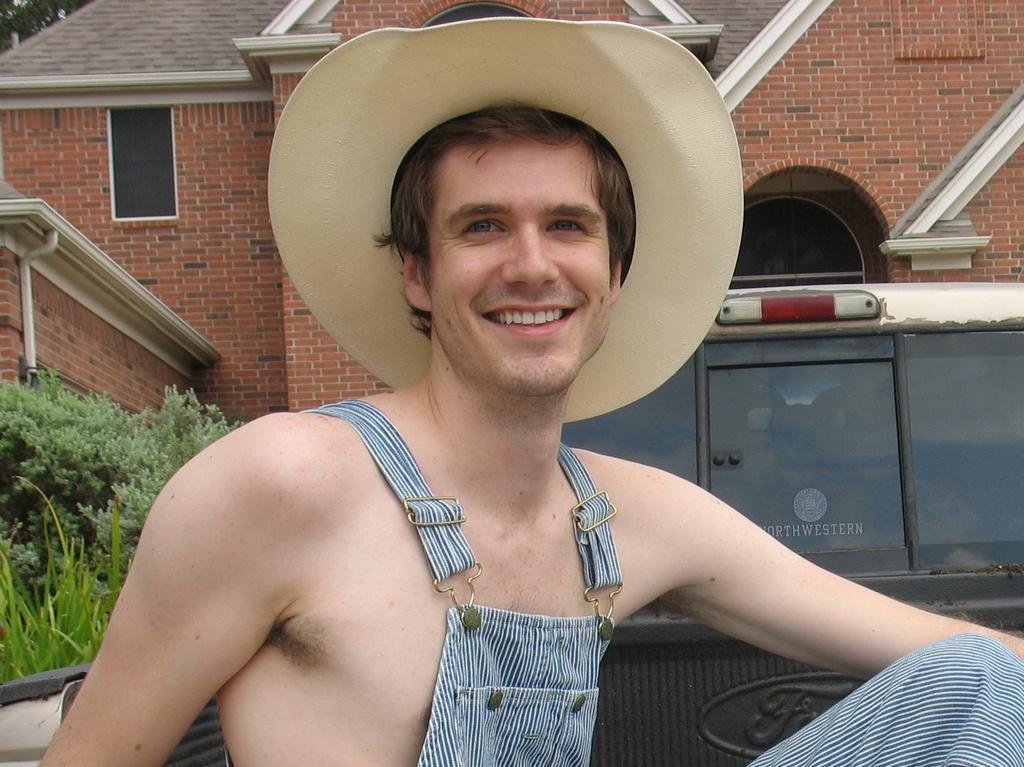How would you summarize this image in a sentence or two? In this image I can see a person with hat. There is a building, a vehicle and also there are plants. 